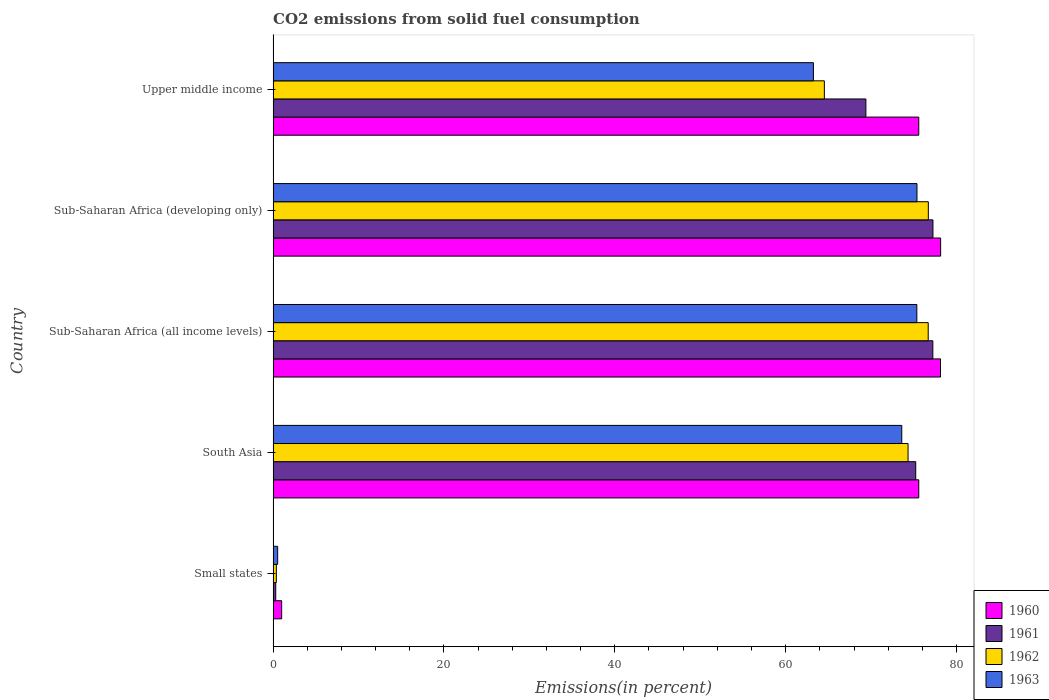Are the number of bars per tick equal to the number of legend labels?
Make the answer very short. Yes. Are the number of bars on each tick of the Y-axis equal?
Provide a short and direct response. Yes. How many bars are there on the 3rd tick from the bottom?
Give a very brief answer. 4. What is the label of the 2nd group of bars from the top?
Make the answer very short. Sub-Saharan Africa (developing only). What is the total CO2 emitted in 1962 in Sub-Saharan Africa (all income levels)?
Make the answer very short. 76.69. Across all countries, what is the maximum total CO2 emitted in 1960?
Keep it short and to the point. 78.14. Across all countries, what is the minimum total CO2 emitted in 1962?
Keep it short and to the point. 0.38. In which country was the total CO2 emitted in 1961 maximum?
Your response must be concise. Sub-Saharan Africa (developing only). In which country was the total CO2 emitted in 1961 minimum?
Provide a short and direct response. Small states. What is the total total CO2 emitted in 1961 in the graph?
Ensure brevity in your answer.  299.4. What is the difference between the total CO2 emitted in 1962 in Small states and that in Sub-Saharan Africa (all income levels)?
Provide a short and direct response. -76.31. What is the difference between the total CO2 emitted in 1963 in Small states and the total CO2 emitted in 1962 in Upper middle income?
Give a very brief answer. -64. What is the average total CO2 emitted in 1960 per country?
Ensure brevity in your answer.  61.69. What is the difference between the total CO2 emitted in 1960 and total CO2 emitted in 1961 in South Asia?
Offer a very short reply. 0.36. In how many countries, is the total CO2 emitted in 1961 greater than 24 %?
Your response must be concise. 4. What is the ratio of the total CO2 emitted in 1960 in Sub-Saharan Africa (all income levels) to that in Upper middle income?
Provide a succinct answer. 1.03. Is the total CO2 emitted in 1961 in South Asia less than that in Sub-Saharan Africa (developing only)?
Offer a terse response. Yes. What is the difference between the highest and the second highest total CO2 emitted in 1960?
Make the answer very short. 0.01. What is the difference between the highest and the lowest total CO2 emitted in 1962?
Give a very brief answer. 76.32. Is the sum of the total CO2 emitted in 1963 in Small states and Sub-Saharan Africa (developing only) greater than the maximum total CO2 emitted in 1962 across all countries?
Give a very brief answer. No. Is it the case that in every country, the sum of the total CO2 emitted in 1961 and total CO2 emitted in 1962 is greater than the sum of total CO2 emitted in 1963 and total CO2 emitted in 1960?
Offer a terse response. No. What does the 4th bar from the top in Sub-Saharan Africa (all income levels) represents?
Ensure brevity in your answer.  1960. What does the 2nd bar from the bottom in Small states represents?
Give a very brief answer. 1961. How many countries are there in the graph?
Make the answer very short. 5. Are the values on the major ticks of X-axis written in scientific E-notation?
Provide a succinct answer. No. Does the graph contain grids?
Provide a succinct answer. No. Where does the legend appear in the graph?
Keep it short and to the point. Bottom right. What is the title of the graph?
Provide a succinct answer. CO2 emissions from solid fuel consumption. Does "1994" appear as one of the legend labels in the graph?
Offer a terse response. No. What is the label or title of the X-axis?
Give a very brief answer. Emissions(in percent). What is the Emissions(in percent) in 1960 in Small states?
Give a very brief answer. 1. What is the Emissions(in percent) in 1961 in Small states?
Make the answer very short. 0.31. What is the Emissions(in percent) of 1962 in Small states?
Your answer should be very brief. 0.38. What is the Emissions(in percent) in 1963 in Small states?
Provide a succinct answer. 0.53. What is the Emissions(in percent) in 1960 in South Asia?
Provide a short and direct response. 75.58. What is the Emissions(in percent) of 1961 in South Asia?
Provide a succinct answer. 75.23. What is the Emissions(in percent) in 1962 in South Asia?
Provide a succinct answer. 74.33. What is the Emissions(in percent) in 1963 in South Asia?
Offer a very short reply. 73.59. What is the Emissions(in percent) of 1960 in Sub-Saharan Africa (all income levels)?
Make the answer very short. 78.13. What is the Emissions(in percent) in 1961 in Sub-Saharan Africa (all income levels)?
Your response must be concise. 77.23. What is the Emissions(in percent) of 1962 in Sub-Saharan Africa (all income levels)?
Ensure brevity in your answer.  76.69. What is the Emissions(in percent) of 1963 in Sub-Saharan Africa (all income levels)?
Make the answer very short. 75.35. What is the Emissions(in percent) of 1960 in Sub-Saharan Africa (developing only)?
Provide a short and direct response. 78.14. What is the Emissions(in percent) in 1961 in Sub-Saharan Africa (developing only)?
Offer a very short reply. 77.24. What is the Emissions(in percent) of 1962 in Sub-Saharan Africa (developing only)?
Make the answer very short. 76.7. What is the Emissions(in percent) in 1963 in Sub-Saharan Africa (developing only)?
Keep it short and to the point. 75.37. What is the Emissions(in percent) in 1960 in Upper middle income?
Offer a very short reply. 75.58. What is the Emissions(in percent) in 1961 in Upper middle income?
Keep it short and to the point. 69.39. What is the Emissions(in percent) of 1962 in Upper middle income?
Your answer should be very brief. 64.53. What is the Emissions(in percent) in 1963 in Upper middle income?
Your response must be concise. 63.25. Across all countries, what is the maximum Emissions(in percent) in 1960?
Provide a succinct answer. 78.14. Across all countries, what is the maximum Emissions(in percent) of 1961?
Offer a very short reply. 77.24. Across all countries, what is the maximum Emissions(in percent) of 1962?
Keep it short and to the point. 76.7. Across all countries, what is the maximum Emissions(in percent) in 1963?
Offer a very short reply. 75.37. Across all countries, what is the minimum Emissions(in percent) of 1960?
Keep it short and to the point. 1. Across all countries, what is the minimum Emissions(in percent) of 1961?
Ensure brevity in your answer.  0.31. Across all countries, what is the minimum Emissions(in percent) in 1962?
Your response must be concise. 0.38. Across all countries, what is the minimum Emissions(in percent) of 1963?
Your response must be concise. 0.53. What is the total Emissions(in percent) of 1960 in the graph?
Provide a succinct answer. 308.43. What is the total Emissions(in percent) of 1961 in the graph?
Keep it short and to the point. 299.4. What is the total Emissions(in percent) in 1962 in the graph?
Keep it short and to the point. 292.62. What is the total Emissions(in percent) in 1963 in the graph?
Keep it short and to the point. 288.1. What is the difference between the Emissions(in percent) in 1960 in Small states and that in South Asia?
Offer a very short reply. -74.58. What is the difference between the Emissions(in percent) of 1961 in Small states and that in South Asia?
Provide a succinct answer. -74.92. What is the difference between the Emissions(in percent) in 1962 in Small states and that in South Asia?
Provide a short and direct response. -73.95. What is the difference between the Emissions(in percent) in 1963 in Small states and that in South Asia?
Offer a terse response. -73.06. What is the difference between the Emissions(in percent) of 1960 in Small states and that in Sub-Saharan Africa (all income levels)?
Offer a terse response. -77.13. What is the difference between the Emissions(in percent) in 1961 in Small states and that in Sub-Saharan Africa (all income levels)?
Keep it short and to the point. -76.92. What is the difference between the Emissions(in percent) in 1962 in Small states and that in Sub-Saharan Africa (all income levels)?
Your answer should be very brief. -76.31. What is the difference between the Emissions(in percent) in 1963 in Small states and that in Sub-Saharan Africa (all income levels)?
Your answer should be very brief. -74.82. What is the difference between the Emissions(in percent) in 1960 in Small states and that in Sub-Saharan Africa (developing only)?
Provide a succinct answer. -77.14. What is the difference between the Emissions(in percent) in 1961 in Small states and that in Sub-Saharan Africa (developing only)?
Provide a succinct answer. -76.94. What is the difference between the Emissions(in percent) of 1962 in Small states and that in Sub-Saharan Africa (developing only)?
Your answer should be compact. -76.32. What is the difference between the Emissions(in percent) of 1963 in Small states and that in Sub-Saharan Africa (developing only)?
Your answer should be compact. -74.84. What is the difference between the Emissions(in percent) in 1960 in Small states and that in Upper middle income?
Keep it short and to the point. -74.58. What is the difference between the Emissions(in percent) of 1961 in Small states and that in Upper middle income?
Ensure brevity in your answer.  -69.09. What is the difference between the Emissions(in percent) of 1962 in Small states and that in Upper middle income?
Offer a very short reply. -64.15. What is the difference between the Emissions(in percent) of 1963 in Small states and that in Upper middle income?
Offer a very short reply. -62.71. What is the difference between the Emissions(in percent) of 1960 in South Asia and that in Sub-Saharan Africa (all income levels)?
Offer a terse response. -2.54. What is the difference between the Emissions(in percent) of 1961 in South Asia and that in Sub-Saharan Africa (all income levels)?
Keep it short and to the point. -2. What is the difference between the Emissions(in percent) of 1962 in South Asia and that in Sub-Saharan Africa (all income levels)?
Give a very brief answer. -2.36. What is the difference between the Emissions(in percent) of 1963 in South Asia and that in Sub-Saharan Africa (all income levels)?
Provide a short and direct response. -1.76. What is the difference between the Emissions(in percent) of 1960 in South Asia and that in Sub-Saharan Africa (developing only)?
Keep it short and to the point. -2.56. What is the difference between the Emissions(in percent) in 1961 in South Asia and that in Sub-Saharan Africa (developing only)?
Offer a terse response. -2.02. What is the difference between the Emissions(in percent) in 1962 in South Asia and that in Sub-Saharan Africa (developing only)?
Ensure brevity in your answer.  -2.37. What is the difference between the Emissions(in percent) in 1963 in South Asia and that in Sub-Saharan Africa (developing only)?
Ensure brevity in your answer.  -1.78. What is the difference between the Emissions(in percent) of 1960 in South Asia and that in Upper middle income?
Your response must be concise. 0. What is the difference between the Emissions(in percent) of 1961 in South Asia and that in Upper middle income?
Offer a very short reply. 5.84. What is the difference between the Emissions(in percent) of 1962 in South Asia and that in Upper middle income?
Give a very brief answer. 9.8. What is the difference between the Emissions(in percent) in 1963 in South Asia and that in Upper middle income?
Offer a very short reply. 10.34. What is the difference between the Emissions(in percent) in 1960 in Sub-Saharan Africa (all income levels) and that in Sub-Saharan Africa (developing only)?
Offer a terse response. -0.01. What is the difference between the Emissions(in percent) in 1961 in Sub-Saharan Africa (all income levels) and that in Sub-Saharan Africa (developing only)?
Give a very brief answer. -0.01. What is the difference between the Emissions(in percent) of 1962 in Sub-Saharan Africa (all income levels) and that in Sub-Saharan Africa (developing only)?
Ensure brevity in your answer.  -0.01. What is the difference between the Emissions(in percent) in 1963 in Sub-Saharan Africa (all income levels) and that in Sub-Saharan Africa (developing only)?
Your answer should be compact. -0.02. What is the difference between the Emissions(in percent) of 1960 in Sub-Saharan Africa (all income levels) and that in Upper middle income?
Keep it short and to the point. 2.54. What is the difference between the Emissions(in percent) of 1961 in Sub-Saharan Africa (all income levels) and that in Upper middle income?
Your answer should be very brief. 7.84. What is the difference between the Emissions(in percent) of 1962 in Sub-Saharan Africa (all income levels) and that in Upper middle income?
Give a very brief answer. 12.16. What is the difference between the Emissions(in percent) of 1963 in Sub-Saharan Africa (all income levels) and that in Upper middle income?
Provide a short and direct response. 12.11. What is the difference between the Emissions(in percent) in 1960 in Sub-Saharan Africa (developing only) and that in Upper middle income?
Your answer should be compact. 2.56. What is the difference between the Emissions(in percent) in 1961 in Sub-Saharan Africa (developing only) and that in Upper middle income?
Provide a succinct answer. 7.85. What is the difference between the Emissions(in percent) of 1962 in Sub-Saharan Africa (developing only) and that in Upper middle income?
Make the answer very short. 12.17. What is the difference between the Emissions(in percent) in 1963 in Sub-Saharan Africa (developing only) and that in Upper middle income?
Provide a succinct answer. 12.13. What is the difference between the Emissions(in percent) of 1960 in Small states and the Emissions(in percent) of 1961 in South Asia?
Offer a terse response. -74.23. What is the difference between the Emissions(in percent) in 1960 in Small states and the Emissions(in percent) in 1962 in South Asia?
Ensure brevity in your answer.  -73.33. What is the difference between the Emissions(in percent) in 1960 in Small states and the Emissions(in percent) in 1963 in South Asia?
Give a very brief answer. -72.59. What is the difference between the Emissions(in percent) in 1961 in Small states and the Emissions(in percent) in 1962 in South Asia?
Provide a succinct answer. -74.02. What is the difference between the Emissions(in percent) in 1961 in Small states and the Emissions(in percent) in 1963 in South Asia?
Offer a terse response. -73.29. What is the difference between the Emissions(in percent) of 1962 in Small states and the Emissions(in percent) of 1963 in South Asia?
Ensure brevity in your answer.  -73.22. What is the difference between the Emissions(in percent) in 1960 in Small states and the Emissions(in percent) in 1961 in Sub-Saharan Africa (all income levels)?
Your answer should be very brief. -76.23. What is the difference between the Emissions(in percent) of 1960 in Small states and the Emissions(in percent) of 1962 in Sub-Saharan Africa (all income levels)?
Make the answer very short. -75.69. What is the difference between the Emissions(in percent) of 1960 in Small states and the Emissions(in percent) of 1963 in Sub-Saharan Africa (all income levels)?
Make the answer very short. -74.36. What is the difference between the Emissions(in percent) of 1961 in Small states and the Emissions(in percent) of 1962 in Sub-Saharan Africa (all income levels)?
Ensure brevity in your answer.  -76.38. What is the difference between the Emissions(in percent) of 1961 in Small states and the Emissions(in percent) of 1963 in Sub-Saharan Africa (all income levels)?
Provide a short and direct response. -75.05. What is the difference between the Emissions(in percent) of 1962 in Small states and the Emissions(in percent) of 1963 in Sub-Saharan Africa (all income levels)?
Your answer should be very brief. -74.98. What is the difference between the Emissions(in percent) in 1960 in Small states and the Emissions(in percent) in 1961 in Sub-Saharan Africa (developing only)?
Offer a very short reply. -76.25. What is the difference between the Emissions(in percent) in 1960 in Small states and the Emissions(in percent) in 1962 in Sub-Saharan Africa (developing only)?
Keep it short and to the point. -75.7. What is the difference between the Emissions(in percent) of 1960 in Small states and the Emissions(in percent) of 1963 in Sub-Saharan Africa (developing only)?
Provide a succinct answer. -74.38. What is the difference between the Emissions(in percent) in 1961 in Small states and the Emissions(in percent) in 1962 in Sub-Saharan Africa (developing only)?
Provide a succinct answer. -76.4. What is the difference between the Emissions(in percent) in 1961 in Small states and the Emissions(in percent) in 1963 in Sub-Saharan Africa (developing only)?
Your answer should be compact. -75.07. What is the difference between the Emissions(in percent) in 1962 in Small states and the Emissions(in percent) in 1963 in Sub-Saharan Africa (developing only)?
Your response must be concise. -75. What is the difference between the Emissions(in percent) in 1960 in Small states and the Emissions(in percent) in 1961 in Upper middle income?
Provide a succinct answer. -68.39. What is the difference between the Emissions(in percent) in 1960 in Small states and the Emissions(in percent) in 1962 in Upper middle income?
Make the answer very short. -63.53. What is the difference between the Emissions(in percent) in 1960 in Small states and the Emissions(in percent) in 1963 in Upper middle income?
Provide a short and direct response. -62.25. What is the difference between the Emissions(in percent) in 1961 in Small states and the Emissions(in percent) in 1962 in Upper middle income?
Your answer should be very brief. -64.22. What is the difference between the Emissions(in percent) in 1961 in Small states and the Emissions(in percent) in 1963 in Upper middle income?
Provide a short and direct response. -62.94. What is the difference between the Emissions(in percent) of 1962 in Small states and the Emissions(in percent) of 1963 in Upper middle income?
Your answer should be compact. -62.87. What is the difference between the Emissions(in percent) of 1960 in South Asia and the Emissions(in percent) of 1961 in Sub-Saharan Africa (all income levels)?
Give a very brief answer. -1.65. What is the difference between the Emissions(in percent) of 1960 in South Asia and the Emissions(in percent) of 1962 in Sub-Saharan Africa (all income levels)?
Offer a very short reply. -1.1. What is the difference between the Emissions(in percent) of 1960 in South Asia and the Emissions(in percent) of 1963 in Sub-Saharan Africa (all income levels)?
Your answer should be very brief. 0.23. What is the difference between the Emissions(in percent) in 1961 in South Asia and the Emissions(in percent) in 1962 in Sub-Saharan Africa (all income levels)?
Give a very brief answer. -1.46. What is the difference between the Emissions(in percent) of 1961 in South Asia and the Emissions(in percent) of 1963 in Sub-Saharan Africa (all income levels)?
Provide a succinct answer. -0.13. What is the difference between the Emissions(in percent) of 1962 in South Asia and the Emissions(in percent) of 1963 in Sub-Saharan Africa (all income levels)?
Provide a succinct answer. -1.03. What is the difference between the Emissions(in percent) of 1960 in South Asia and the Emissions(in percent) of 1961 in Sub-Saharan Africa (developing only)?
Your response must be concise. -1.66. What is the difference between the Emissions(in percent) of 1960 in South Asia and the Emissions(in percent) of 1962 in Sub-Saharan Africa (developing only)?
Make the answer very short. -1.12. What is the difference between the Emissions(in percent) of 1960 in South Asia and the Emissions(in percent) of 1963 in Sub-Saharan Africa (developing only)?
Ensure brevity in your answer.  0.21. What is the difference between the Emissions(in percent) in 1961 in South Asia and the Emissions(in percent) in 1962 in Sub-Saharan Africa (developing only)?
Your answer should be very brief. -1.47. What is the difference between the Emissions(in percent) of 1961 in South Asia and the Emissions(in percent) of 1963 in Sub-Saharan Africa (developing only)?
Offer a very short reply. -0.15. What is the difference between the Emissions(in percent) in 1962 in South Asia and the Emissions(in percent) in 1963 in Sub-Saharan Africa (developing only)?
Keep it short and to the point. -1.04. What is the difference between the Emissions(in percent) of 1960 in South Asia and the Emissions(in percent) of 1961 in Upper middle income?
Your response must be concise. 6.19. What is the difference between the Emissions(in percent) of 1960 in South Asia and the Emissions(in percent) of 1962 in Upper middle income?
Give a very brief answer. 11.05. What is the difference between the Emissions(in percent) of 1960 in South Asia and the Emissions(in percent) of 1963 in Upper middle income?
Your response must be concise. 12.33. What is the difference between the Emissions(in percent) in 1961 in South Asia and the Emissions(in percent) in 1962 in Upper middle income?
Your response must be concise. 10.7. What is the difference between the Emissions(in percent) in 1961 in South Asia and the Emissions(in percent) in 1963 in Upper middle income?
Give a very brief answer. 11.98. What is the difference between the Emissions(in percent) of 1962 in South Asia and the Emissions(in percent) of 1963 in Upper middle income?
Give a very brief answer. 11.08. What is the difference between the Emissions(in percent) in 1960 in Sub-Saharan Africa (all income levels) and the Emissions(in percent) in 1961 in Sub-Saharan Africa (developing only)?
Your answer should be compact. 0.88. What is the difference between the Emissions(in percent) in 1960 in Sub-Saharan Africa (all income levels) and the Emissions(in percent) in 1962 in Sub-Saharan Africa (developing only)?
Offer a terse response. 1.42. What is the difference between the Emissions(in percent) in 1960 in Sub-Saharan Africa (all income levels) and the Emissions(in percent) in 1963 in Sub-Saharan Africa (developing only)?
Keep it short and to the point. 2.75. What is the difference between the Emissions(in percent) in 1961 in Sub-Saharan Africa (all income levels) and the Emissions(in percent) in 1962 in Sub-Saharan Africa (developing only)?
Ensure brevity in your answer.  0.53. What is the difference between the Emissions(in percent) in 1961 in Sub-Saharan Africa (all income levels) and the Emissions(in percent) in 1963 in Sub-Saharan Africa (developing only)?
Your answer should be compact. 1.86. What is the difference between the Emissions(in percent) in 1962 in Sub-Saharan Africa (all income levels) and the Emissions(in percent) in 1963 in Sub-Saharan Africa (developing only)?
Make the answer very short. 1.31. What is the difference between the Emissions(in percent) of 1960 in Sub-Saharan Africa (all income levels) and the Emissions(in percent) of 1961 in Upper middle income?
Ensure brevity in your answer.  8.73. What is the difference between the Emissions(in percent) in 1960 in Sub-Saharan Africa (all income levels) and the Emissions(in percent) in 1962 in Upper middle income?
Give a very brief answer. 13.6. What is the difference between the Emissions(in percent) in 1960 in Sub-Saharan Africa (all income levels) and the Emissions(in percent) in 1963 in Upper middle income?
Offer a terse response. 14.88. What is the difference between the Emissions(in percent) in 1961 in Sub-Saharan Africa (all income levels) and the Emissions(in percent) in 1962 in Upper middle income?
Your response must be concise. 12.7. What is the difference between the Emissions(in percent) in 1961 in Sub-Saharan Africa (all income levels) and the Emissions(in percent) in 1963 in Upper middle income?
Provide a succinct answer. 13.98. What is the difference between the Emissions(in percent) of 1962 in Sub-Saharan Africa (all income levels) and the Emissions(in percent) of 1963 in Upper middle income?
Give a very brief answer. 13.44. What is the difference between the Emissions(in percent) in 1960 in Sub-Saharan Africa (developing only) and the Emissions(in percent) in 1961 in Upper middle income?
Your response must be concise. 8.75. What is the difference between the Emissions(in percent) of 1960 in Sub-Saharan Africa (developing only) and the Emissions(in percent) of 1962 in Upper middle income?
Make the answer very short. 13.61. What is the difference between the Emissions(in percent) of 1960 in Sub-Saharan Africa (developing only) and the Emissions(in percent) of 1963 in Upper middle income?
Make the answer very short. 14.89. What is the difference between the Emissions(in percent) in 1961 in Sub-Saharan Africa (developing only) and the Emissions(in percent) in 1962 in Upper middle income?
Offer a terse response. 12.71. What is the difference between the Emissions(in percent) in 1961 in Sub-Saharan Africa (developing only) and the Emissions(in percent) in 1963 in Upper middle income?
Your answer should be very brief. 14. What is the difference between the Emissions(in percent) in 1962 in Sub-Saharan Africa (developing only) and the Emissions(in percent) in 1963 in Upper middle income?
Your answer should be compact. 13.45. What is the average Emissions(in percent) in 1960 per country?
Your answer should be compact. 61.69. What is the average Emissions(in percent) in 1961 per country?
Ensure brevity in your answer.  59.88. What is the average Emissions(in percent) in 1962 per country?
Your answer should be very brief. 58.52. What is the average Emissions(in percent) of 1963 per country?
Your answer should be compact. 57.62. What is the difference between the Emissions(in percent) of 1960 and Emissions(in percent) of 1961 in Small states?
Your response must be concise. 0.69. What is the difference between the Emissions(in percent) of 1960 and Emissions(in percent) of 1962 in Small states?
Ensure brevity in your answer.  0.62. What is the difference between the Emissions(in percent) of 1960 and Emissions(in percent) of 1963 in Small states?
Provide a succinct answer. 0.46. What is the difference between the Emissions(in percent) of 1961 and Emissions(in percent) of 1962 in Small states?
Make the answer very short. -0.07. What is the difference between the Emissions(in percent) of 1961 and Emissions(in percent) of 1963 in Small states?
Provide a succinct answer. -0.23. What is the difference between the Emissions(in percent) of 1962 and Emissions(in percent) of 1963 in Small states?
Ensure brevity in your answer.  -0.16. What is the difference between the Emissions(in percent) of 1960 and Emissions(in percent) of 1961 in South Asia?
Offer a very short reply. 0.36. What is the difference between the Emissions(in percent) in 1960 and Emissions(in percent) in 1962 in South Asia?
Your answer should be compact. 1.25. What is the difference between the Emissions(in percent) of 1960 and Emissions(in percent) of 1963 in South Asia?
Your response must be concise. 1.99. What is the difference between the Emissions(in percent) in 1961 and Emissions(in percent) in 1962 in South Asia?
Give a very brief answer. 0.9. What is the difference between the Emissions(in percent) of 1961 and Emissions(in percent) of 1963 in South Asia?
Your response must be concise. 1.63. What is the difference between the Emissions(in percent) of 1962 and Emissions(in percent) of 1963 in South Asia?
Give a very brief answer. 0.74. What is the difference between the Emissions(in percent) of 1960 and Emissions(in percent) of 1961 in Sub-Saharan Africa (all income levels)?
Your answer should be compact. 0.9. What is the difference between the Emissions(in percent) in 1960 and Emissions(in percent) in 1962 in Sub-Saharan Africa (all income levels)?
Keep it short and to the point. 1.44. What is the difference between the Emissions(in percent) in 1960 and Emissions(in percent) in 1963 in Sub-Saharan Africa (all income levels)?
Offer a terse response. 2.77. What is the difference between the Emissions(in percent) in 1961 and Emissions(in percent) in 1962 in Sub-Saharan Africa (all income levels)?
Provide a succinct answer. 0.54. What is the difference between the Emissions(in percent) of 1961 and Emissions(in percent) of 1963 in Sub-Saharan Africa (all income levels)?
Offer a very short reply. 1.88. What is the difference between the Emissions(in percent) of 1962 and Emissions(in percent) of 1963 in Sub-Saharan Africa (all income levels)?
Provide a succinct answer. 1.33. What is the difference between the Emissions(in percent) in 1960 and Emissions(in percent) in 1961 in Sub-Saharan Africa (developing only)?
Provide a short and direct response. 0.9. What is the difference between the Emissions(in percent) in 1960 and Emissions(in percent) in 1962 in Sub-Saharan Africa (developing only)?
Provide a short and direct response. 1.44. What is the difference between the Emissions(in percent) in 1960 and Emissions(in percent) in 1963 in Sub-Saharan Africa (developing only)?
Your response must be concise. 2.77. What is the difference between the Emissions(in percent) in 1961 and Emissions(in percent) in 1962 in Sub-Saharan Africa (developing only)?
Your response must be concise. 0.54. What is the difference between the Emissions(in percent) in 1961 and Emissions(in percent) in 1963 in Sub-Saharan Africa (developing only)?
Give a very brief answer. 1.87. What is the difference between the Emissions(in percent) in 1962 and Emissions(in percent) in 1963 in Sub-Saharan Africa (developing only)?
Your answer should be very brief. 1.33. What is the difference between the Emissions(in percent) in 1960 and Emissions(in percent) in 1961 in Upper middle income?
Provide a succinct answer. 6.19. What is the difference between the Emissions(in percent) in 1960 and Emissions(in percent) in 1962 in Upper middle income?
Your answer should be very brief. 11.05. What is the difference between the Emissions(in percent) in 1960 and Emissions(in percent) in 1963 in Upper middle income?
Your response must be concise. 12.33. What is the difference between the Emissions(in percent) in 1961 and Emissions(in percent) in 1962 in Upper middle income?
Ensure brevity in your answer.  4.86. What is the difference between the Emissions(in percent) of 1961 and Emissions(in percent) of 1963 in Upper middle income?
Ensure brevity in your answer.  6.14. What is the difference between the Emissions(in percent) in 1962 and Emissions(in percent) in 1963 in Upper middle income?
Make the answer very short. 1.28. What is the ratio of the Emissions(in percent) in 1960 in Small states to that in South Asia?
Make the answer very short. 0.01. What is the ratio of the Emissions(in percent) of 1961 in Small states to that in South Asia?
Keep it short and to the point. 0. What is the ratio of the Emissions(in percent) of 1962 in Small states to that in South Asia?
Provide a short and direct response. 0.01. What is the ratio of the Emissions(in percent) of 1963 in Small states to that in South Asia?
Offer a terse response. 0.01. What is the ratio of the Emissions(in percent) of 1960 in Small states to that in Sub-Saharan Africa (all income levels)?
Give a very brief answer. 0.01. What is the ratio of the Emissions(in percent) in 1961 in Small states to that in Sub-Saharan Africa (all income levels)?
Keep it short and to the point. 0. What is the ratio of the Emissions(in percent) in 1962 in Small states to that in Sub-Saharan Africa (all income levels)?
Give a very brief answer. 0. What is the ratio of the Emissions(in percent) in 1963 in Small states to that in Sub-Saharan Africa (all income levels)?
Offer a very short reply. 0.01. What is the ratio of the Emissions(in percent) of 1960 in Small states to that in Sub-Saharan Africa (developing only)?
Make the answer very short. 0.01. What is the ratio of the Emissions(in percent) of 1961 in Small states to that in Sub-Saharan Africa (developing only)?
Your answer should be compact. 0. What is the ratio of the Emissions(in percent) in 1962 in Small states to that in Sub-Saharan Africa (developing only)?
Offer a terse response. 0. What is the ratio of the Emissions(in percent) of 1963 in Small states to that in Sub-Saharan Africa (developing only)?
Your response must be concise. 0.01. What is the ratio of the Emissions(in percent) in 1960 in Small states to that in Upper middle income?
Your answer should be compact. 0.01. What is the ratio of the Emissions(in percent) in 1961 in Small states to that in Upper middle income?
Offer a terse response. 0. What is the ratio of the Emissions(in percent) in 1962 in Small states to that in Upper middle income?
Offer a very short reply. 0.01. What is the ratio of the Emissions(in percent) in 1963 in Small states to that in Upper middle income?
Your answer should be compact. 0.01. What is the ratio of the Emissions(in percent) of 1960 in South Asia to that in Sub-Saharan Africa (all income levels)?
Offer a terse response. 0.97. What is the ratio of the Emissions(in percent) in 1961 in South Asia to that in Sub-Saharan Africa (all income levels)?
Offer a very short reply. 0.97. What is the ratio of the Emissions(in percent) of 1962 in South Asia to that in Sub-Saharan Africa (all income levels)?
Your answer should be compact. 0.97. What is the ratio of the Emissions(in percent) in 1963 in South Asia to that in Sub-Saharan Africa (all income levels)?
Keep it short and to the point. 0.98. What is the ratio of the Emissions(in percent) in 1960 in South Asia to that in Sub-Saharan Africa (developing only)?
Offer a terse response. 0.97. What is the ratio of the Emissions(in percent) in 1961 in South Asia to that in Sub-Saharan Africa (developing only)?
Your response must be concise. 0.97. What is the ratio of the Emissions(in percent) of 1962 in South Asia to that in Sub-Saharan Africa (developing only)?
Ensure brevity in your answer.  0.97. What is the ratio of the Emissions(in percent) in 1963 in South Asia to that in Sub-Saharan Africa (developing only)?
Offer a very short reply. 0.98. What is the ratio of the Emissions(in percent) of 1961 in South Asia to that in Upper middle income?
Your answer should be compact. 1.08. What is the ratio of the Emissions(in percent) in 1962 in South Asia to that in Upper middle income?
Offer a very short reply. 1.15. What is the ratio of the Emissions(in percent) in 1963 in South Asia to that in Upper middle income?
Your answer should be compact. 1.16. What is the ratio of the Emissions(in percent) of 1961 in Sub-Saharan Africa (all income levels) to that in Sub-Saharan Africa (developing only)?
Make the answer very short. 1. What is the ratio of the Emissions(in percent) of 1962 in Sub-Saharan Africa (all income levels) to that in Sub-Saharan Africa (developing only)?
Give a very brief answer. 1. What is the ratio of the Emissions(in percent) in 1960 in Sub-Saharan Africa (all income levels) to that in Upper middle income?
Offer a terse response. 1.03. What is the ratio of the Emissions(in percent) in 1961 in Sub-Saharan Africa (all income levels) to that in Upper middle income?
Provide a short and direct response. 1.11. What is the ratio of the Emissions(in percent) of 1962 in Sub-Saharan Africa (all income levels) to that in Upper middle income?
Offer a very short reply. 1.19. What is the ratio of the Emissions(in percent) in 1963 in Sub-Saharan Africa (all income levels) to that in Upper middle income?
Your response must be concise. 1.19. What is the ratio of the Emissions(in percent) in 1960 in Sub-Saharan Africa (developing only) to that in Upper middle income?
Offer a very short reply. 1.03. What is the ratio of the Emissions(in percent) in 1961 in Sub-Saharan Africa (developing only) to that in Upper middle income?
Your answer should be compact. 1.11. What is the ratio of the Emissions(in percent) in 1962 in Sub-Saharan Africa (developing only) to that in Upper middle income?
Your answer should be compact. 1.19. What is the ratio of the Emissions(in percent) in 1963 in Sub-Saharan Africa (developing only) to that in Upper middle income?
Offer a very short reply. 1.19. What is the difference between the highest and the second highest Emissions(in percent) in 1960?
Provide a short and direct response. 0.01. What is the difference between the highest and the second highest Emissions(in percent) in 1961?
Make the answer very short. 0.01. What is the difference between the highest and the second highest Emissions(in percent) of 1962?
Make the answer very short. 0.01. What is the difference between the highest and the second highest Emissions(in percent) in 1963?
Keep it short and to the point. 0.02. What is the difference between the highest and the lowest Emissions(in percent) in 1960?
Your response must be concise. 77.14. What is the difference between the highest and the lowest Emissions(in percent) in 1961?
Make the answer very short. 76.94. What is the difference between the highest and the lowest Emissions(in percent) in 1962?
Keep it short and to the point. 76.32. What is the difference between the highest and the lowest Emissions(in percent) in 1963?
Provide a short and direct response. 74.84. 